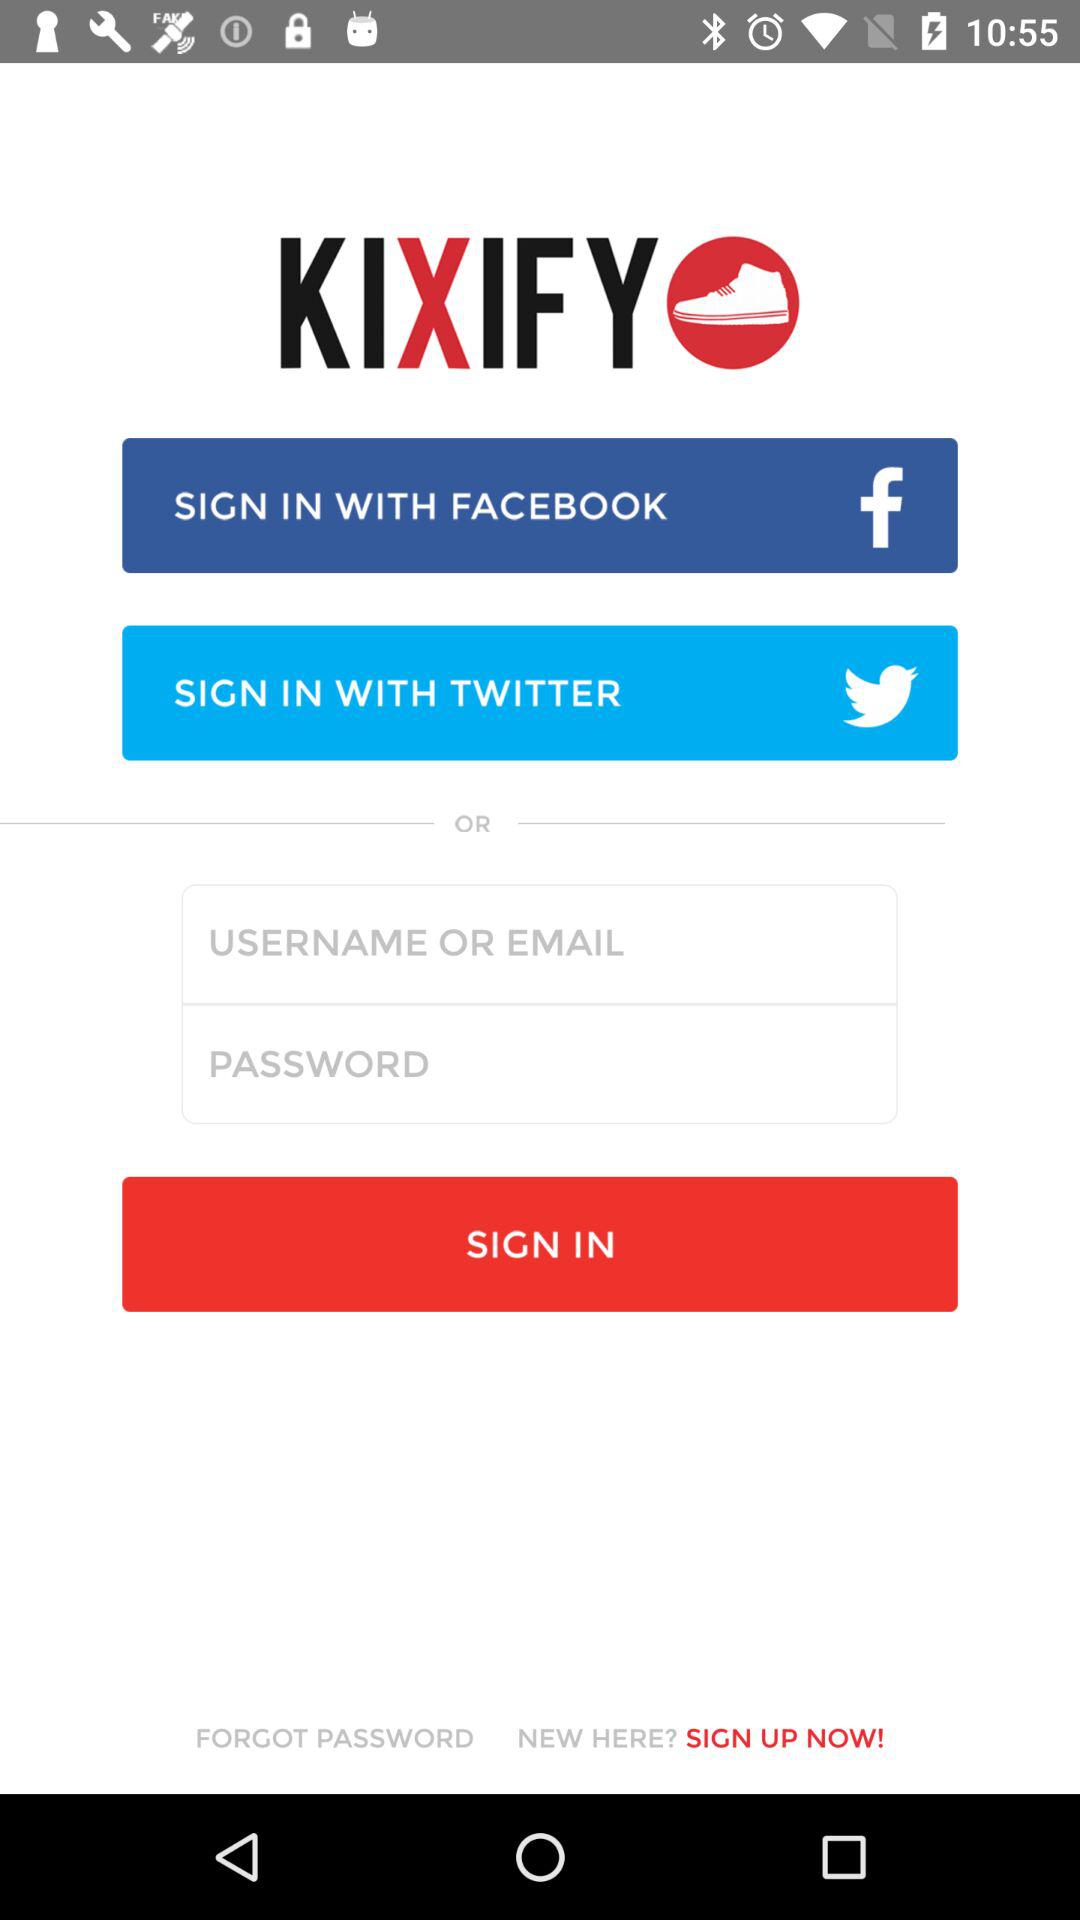What are the different sign in options? The different sign in options are "FACEBOOK" and "TWITTER". 